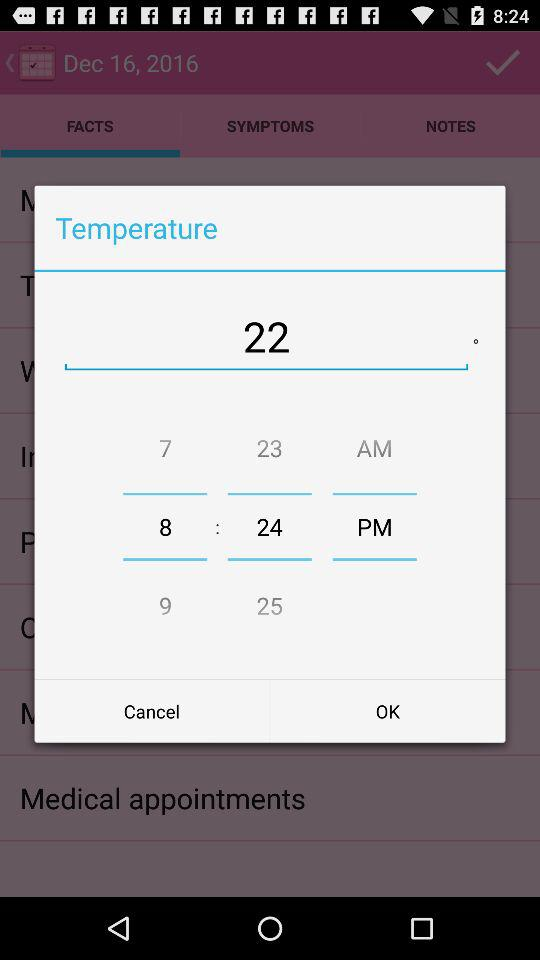What is the mentioned date? The mentioned date is December 16, 2016. 